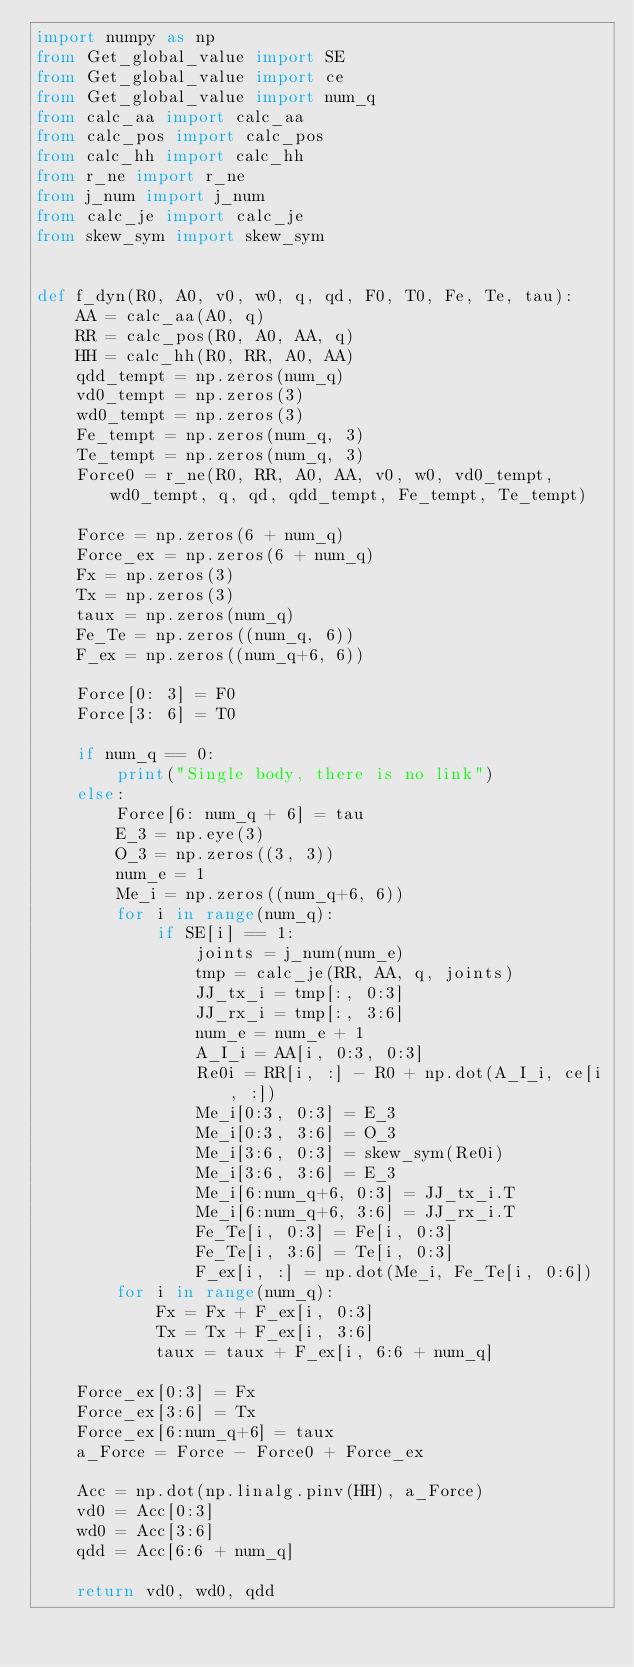Convert code to text. <code><loc_0><loc_0><loc_500><loc_500><_Python_>import numpy as np
from Get_global_value import SE
from Get_global_value import ce
from Get_global_value import num_q
from calc_aa import calc_aa
from calc_pos import calc_pos
from calc_hh import calc_hh
from r_ne import r_ne
from j_num import j_num
from calc_je import calc_je
from skew_sym import skew_sym


def f_dyn(R0, A0, v0, w0, q, qd, F0, T0, Fe, Te, tau):
    AA = calc_aa(A0, q)
    RR = calc_pos(R0, A0, AA, q)
    HH = calc_hh(R0, RR, A0, AA)
    qdd_tempt = np.zeros(num_q)
    vd0_tempt = np.zeros(3)
    wd0_tempt = np.zeros(3)
    Fe_tempt = np.zeros(num_q, 3)
    Te_tempt = np.zeros(num_q, 3)
    Force0 = r_ne(R0, RR, A0, AA, v0, w0, vd0_tempt, wd0_tempt, q, qd, qdd_tempt, Fe_tempt, Te_tempt)

    Force = np.zeros(6 + num_q)
    Force_ex = np.zeros(6 + num_q)
    Fx = np.zeros(3)
    Tx = np.zeros(3)
    taux = np.zeros(num_q)
    Fe_Te = np.zeros((num_q, 6))
    F_ex = np.zeros((num_q+6, 6))

    Force[0: 3] = F0
    Force[3: 6] = T0

    if num_q == 0:
        print("Single body, there is no link")
    else:
        Force[6: num_q + 6] = tau
        E_3 = np.eye(3)
        O_3 = np.zeros((3, 3))
        num_e = 1
        Me_i = np.zeros((num_q+6, 6))
        for i in range(num_q):
            if SE[i] == 1:
                joints = j_num(num_e)
                tmp = calc_je(RR, AA, q, joints)
                JJ_tx_i = tmp[:, 0:3]
                JJ_rx_i = tmp[:, 3:6]
                num_e = num_e + 1
                A_I_i = AA[i, 0:3, 0:3]
                Re0i = RR[i, :] - R0 + np.dot(A_I_i, ce[i, :])
                Me_i[0:3, 0:3] = E_3
                Me_i[0:3, 3:6] = O_3
                Me_i[3:6, 0:3] = skew_sym(Re0i)
                Me_i[3:6, 3:6] = E_3
                Me_i[6:num_q+6, 0:3] = JJ_tx_i.T
                Me_i[6:num_q+6, 3:6] = JJ_rx_i.T
                Fe_Te[i, 0:3] = Fe[i, 0:3]
                Fe_Te[i, 3:6] = Te[i, 0:3]
                F_ex[i, :] = np.dot(Me_i, Fe_Te[i, 0:6])
        for i in range(num_q):
            Fx = Fx + F_ex[i, 0:3]
            Tx = Tx + F_ex[i, 3:6]
            taux = taux + F_ex[i, 6:6 + num_q]

    Force_ex[0:3] = Fx
    Force_ex[3:6] = Tx
    Force_ex[6:num_q+6] = taux
    a_Force = Force - Force0 + Force_ex

    Acc = np.dot(np.linalg.pinv(HH), a_Force)
    vd0 = Acc[0:3]
    wd0 = Acc[3:6]
    qdd = Acc[6:6 + num_q]

    return vd0, wd0, qdd
</code> 